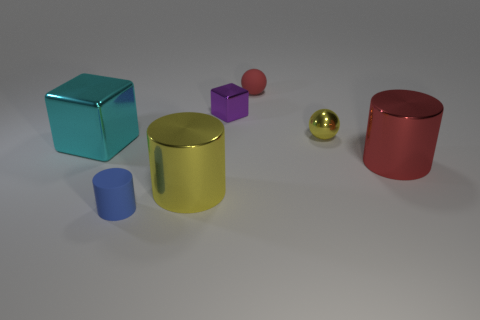What number of rubber things are both behind the purple object and to the left of the big yellow shiny thing?
Your answer should be compact. 0. How many yellow things are metal blocks or small cylinders?
Ensure brevity in your answer.  0. What number of matte things are small yellow things or tiny blocks?
Ensure brevity in your answer.  0. Is there a large gray rubber cylinder?
Give a very brief answer. No. Is the shape of the cyan thing the same as the small blue matte object?
Your answer should be compact. No. How many metal things are in front of the cylinder that is on the left side of the large shiny cylinder that is to the left of the tiny yellow shiny ball?
Your answer should be very brief. 0. There is a tiny object that is on the right side of the yellow cylinder and left of the small red rubber sphere; what is its material?
Keep it short and to the point. Metal. There is a large shiny object that is to the right of the large cyan object and behind the big yellow metal cylinder; what is its color?
Your answer should be very brief. Red. Is there anything else of the same color as the large cube?
Your answer should be very brief. No. There is a big metallic object right of the small shiny object that is on the right side of the metal cube on the right side of the small blue thing; what shape is it?
Your answer should be compact. Cylinder. 